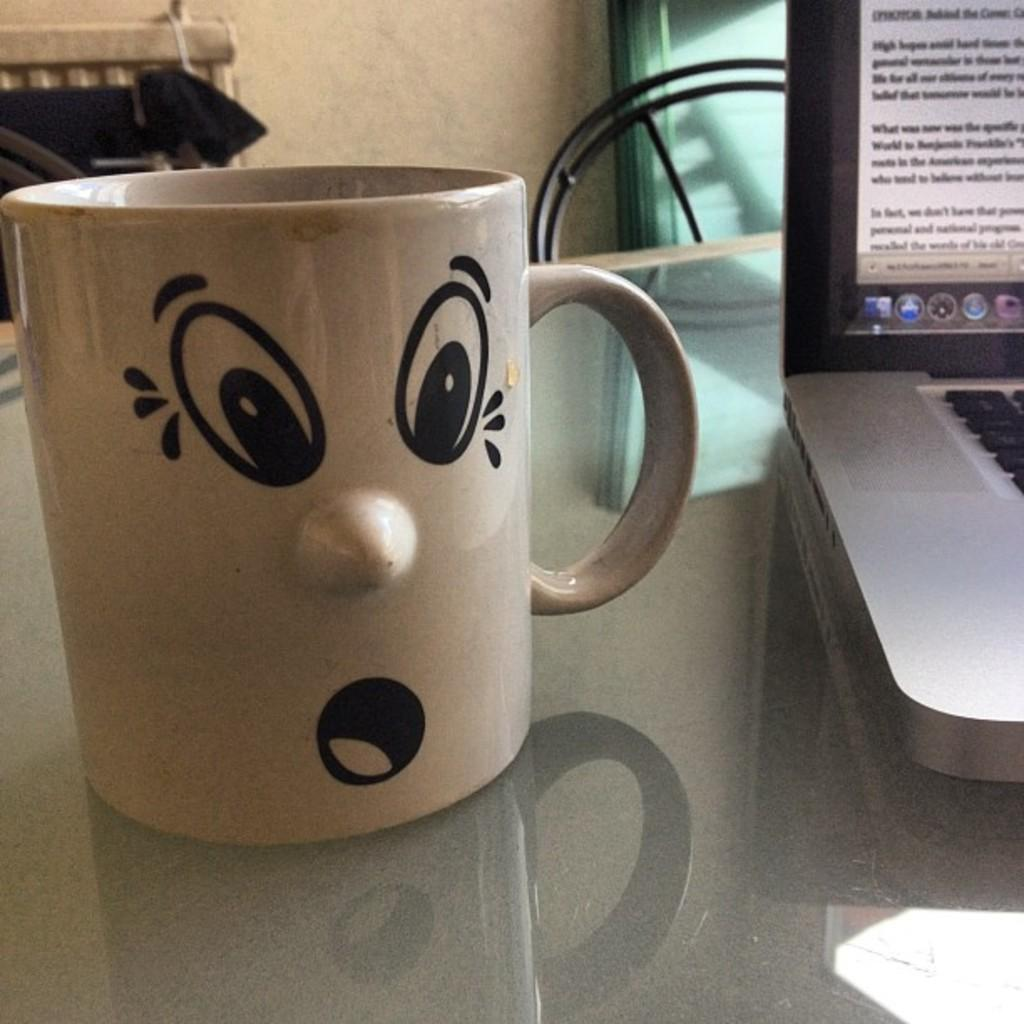What is placed on the table in the image? There is a cup and a laptop placed on a table in the image. What is the purpose of the laptop in the image? The purpose of the laptop is not specified in the image, but it is likely being used for some task or activity. What is the cloth used for in the image? The cloth is placed on a chair, which suggests it might be used for covering or decorating the chair. Where is the chair located in the image? The chair is on the left side of the image. What is visible at the top of the image? There is a wall visible at the top of the image. How many pies are being controlled by the cup in the image? There are no pies or any control mechanism involving the cup in the image. 